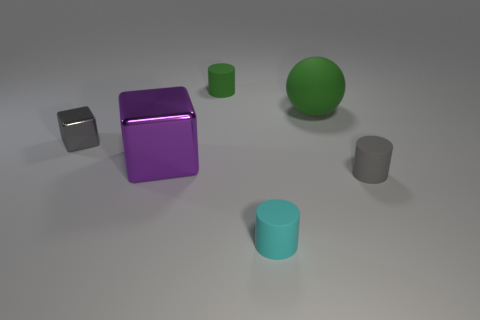Subtract all small cyan cylinders. How many cylinders are left? 2 Subtract all gray cylinders. How many cylinders are left? 2 Add 2 tiny shiny objects. How many objects exist? 8 Subtract all cubes. How many objects are left? 4 Subtract all yellow cubes. Subtract all purple spheres. How many cubes are left? 2 Subtract all blue spheres. How many green cylinders are left? 1 Subtract all small gray cylinders. Subtract all large metal cubes. How many objects are left? 4 Add 1 cyan rubber objects. How many cyan rubber objects are left? 2 Add 2 small cylinders. How many small cylinders exist? 5 Subtract 0 blue cylinders. How many objects are left? 6 